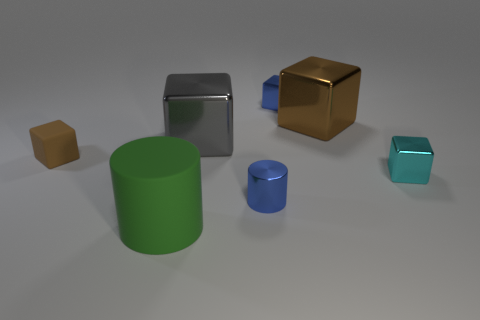Can you guess the possible sizes of these objects in relation to each other? Judging by the perspective, all objects appear to be relatively small, similar to tabletop game pieces. The two cubes and the two cylinders each seem to be of similar sizes respectively, with one cube and one cylinder noticeably smaller, suggesting a 'tiny' variant of their larger counterparts. 